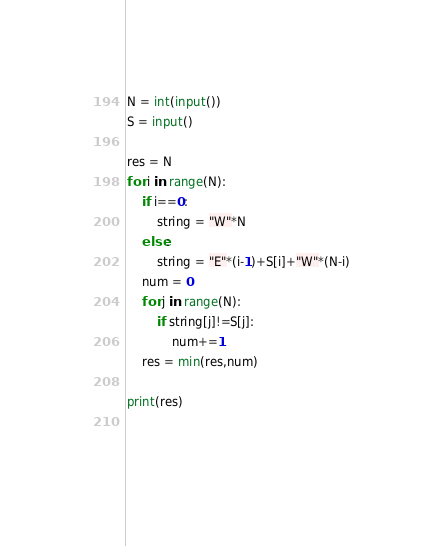Convert code to text. <code><loc_0><loc_0><loc_500><loc_500><_Python_>N = int(input())
S = input()

res = N
for i in range(N):
    if i==0:
        string = "W"*N
    else:
        string = "E"*(i-1)+S[i]+"W"*(N-i)
    num = 0
    for j in range(N):
        if string[j]!=S[j]:
            num+=1
    res = min(res,num)
    
print(res)
    
    
</code> 